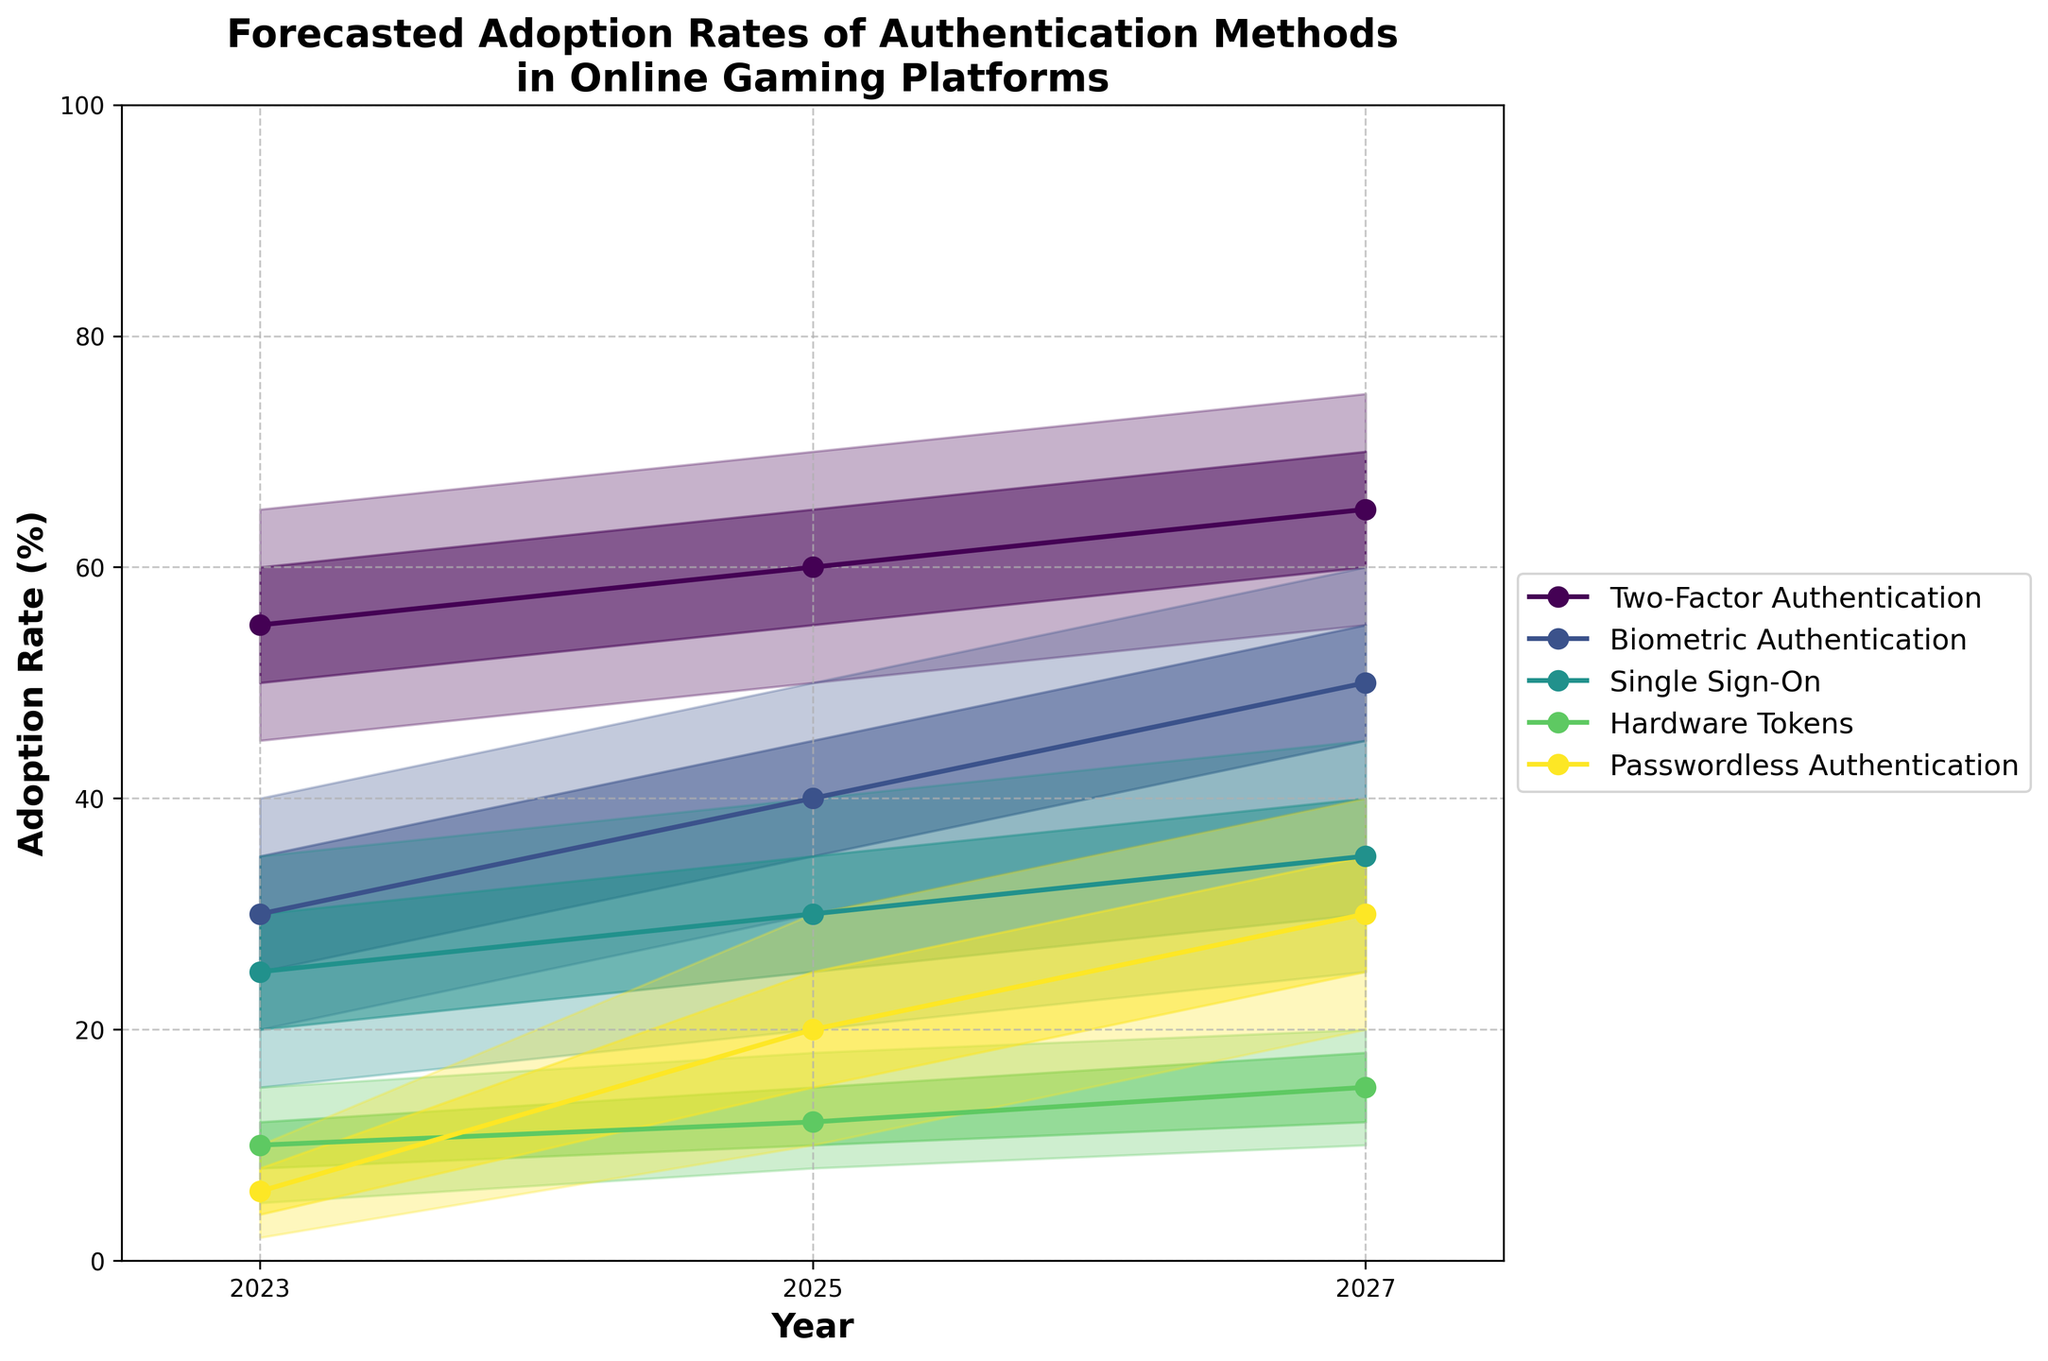What is the title of the figure? The title of the figure can be found at the top, above the chart area.
Answer: Forecasted Adoption Rates of Authentication Methods in Online Gaming Platforms What are the years represented on the x-axis? The information about the years is listed along the x-axis of the chart.
Answer: 2023, 2025, 2027 Which authentication method has the highest mid-range adoption rate in 2027? The mid-range adoption rate for 2027 can be found where the midpoint lines are marked for each method.
Answer: Two-Factor Authentication What is the range of forecasted adoption rates for Biometric Authentication in 2025? The forecasted adoption rate range for a specific year and method can be determined by finding the low and high values. For 2025, Biometric Authentication ranges from the lowest to the highest percent.
Answer: 30% to 50% By how many percentage points is the high adoption rate of Passwordless Authentication in 2027 higher than in 2023? Compare the high adoption rates of Passwordless Authentication for the years 2027 and 2023 and calculate the difference.
Answer: 30% Which authentication method shows the smallest increase in the mid-range forecast from 2023 to 2027? By comparing the mid-range forecast values of each method between 2023 and 2027, the least increase can be identified.
Answer: Two-Factor Authentication How does the adoption rate of Hardware Tokens in 2025 compare to that of Single Sign-On in the same year? Compare the mid-range adoption rates for both Hardware Tokens and Single Sign-On for the year 2025 to see which is higher or lower.
Answer: Hardware Tokens adoption rate is lower than Single Sign-On What's the average mid-range forecast adoption rate of Passwordless Authentication across the years 2023, 2025, and 2027? Sum the mid-range forecast adoption rates of Passwordless Authentication for the years 2023, 2025, and 2027 and divide by 3. (6% + 20% + 30%) / 3 = 56% / 3 = 18.67%
Answer: 18.67% Which authentication method shows the greatest increase in the high forecast adoption rate from 2023 to 2027? Identify all high forecast adoption rates in 2023 and 2027 for each method and calculate the difference to find the greatest increase.
Answer: Passwordless Authentication 